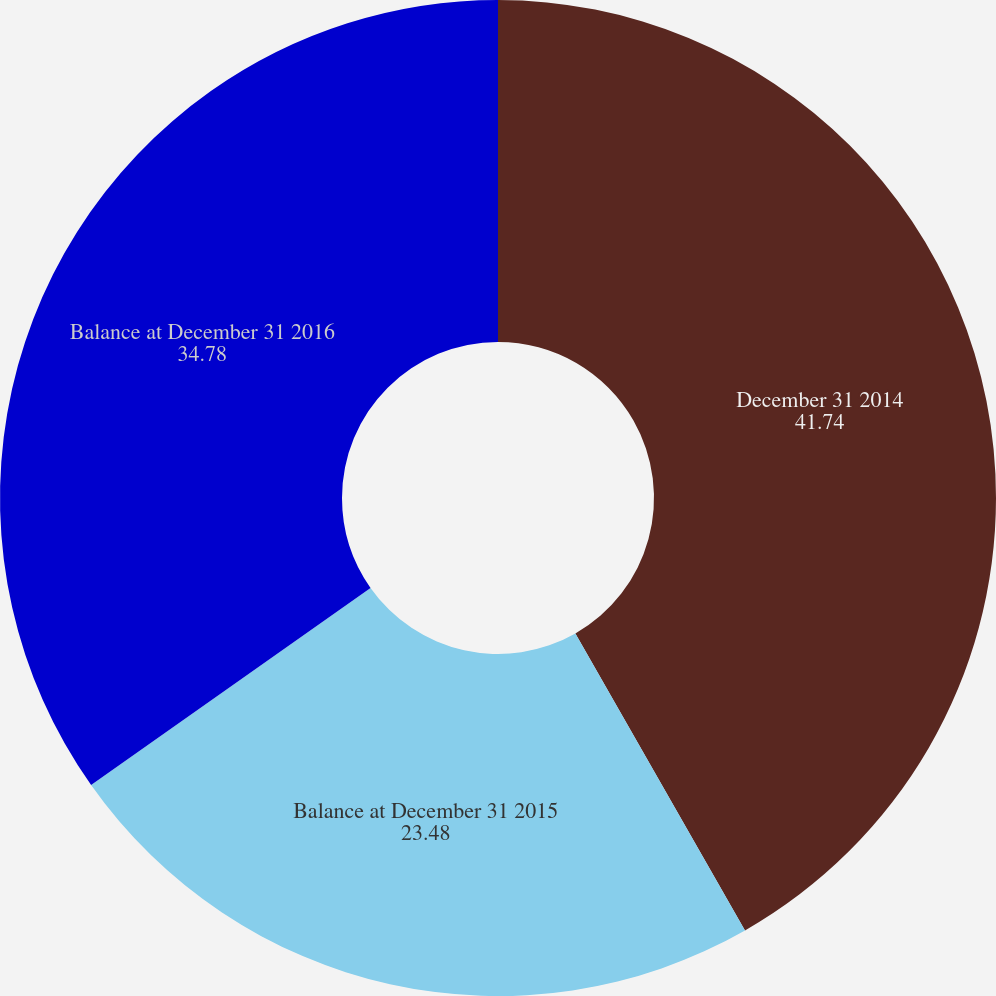Convert chart. <chart><loc_0><loc_0><loc_500><loc_500><pie_chart><fcel>December 31 2014<fcel>Balance at December 31 2015<fcel>Balance at December 31 2016<nl><fcel>41.74%<fcel>23.48%<fcel>34.78%<nl></chart> 